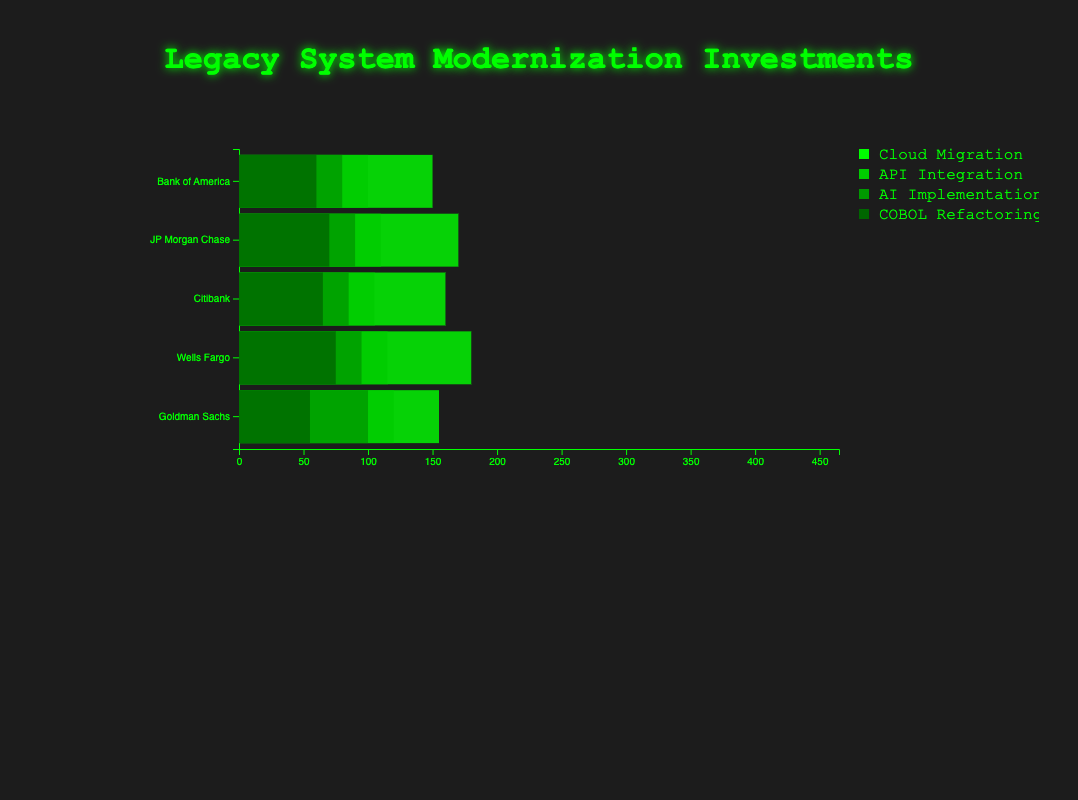What is the total allocated budget for AI implementation across all financial institutions? To find the total allocated budget for AI implementation, sum the allocated budgets from all financial institutions: (80 + 90 + 85 + 95 + 100) = 450.
Answer: 450 Which financial institution has the highest utilized budget for COBOL refactoring? Compare the utilized budgets for COBOL refactoring among all financial institutions. Bank of America utilized 60, JP Morgan Chase 68, Citibank 63, Wells Fargo 70, and Goldman Sachs 53. Wells Fargo has the highest utilized budget at 70.
Answer: Wells Fargo What is the difference between the allocated and utilized budget for cloud migration in Citibank? Subtract the utilized budget from the allocated budget for cloud migration in Citibank: 160 - 140 = 20.
Answer: 20 Which financial institution has the least total allocated budget across all modernization strategies? Sum the allocated budgets for each financial institution and compare them. Bank of America: (150 + 100 + 80 + 60) = 390, JP Morgan Chase: (170 + 110 + 90 + 70) = 440, Citibank: (160 + 105 + 85 + 65) = 415, Wells Fargo: (180 + 115 + 95 + 75) = 465, Goldman Sachs: (155 + 120 + 100 + 55) = 430. Bank of America has the least total allocated budget at 390.
Answer: Bank of America What is the average utilized budget for API integration across all financial institutions? Sum the utilized budgets for API integration from all financial institutions and divide by the number of institutions: (90 + 105 + 100 + 110 + 115) / 5 = 520 / 5 = 104.
Answer: 104 How does the allocated budget for cloud migration in JP Morgan Chase compare to that in Wells Fargo? Compare the allocated budget for cloud migration between JP Morgan Chase (170) and Wells Fargo (180). Wells Fargo has a larger allocated budget by 10 (180 - 170 = 10).
Answer: Wells Fargo allocated 10 more Which modernization strategy has the highest total utilized budget across all financial institutions? Sum the utilized budgets for each strategy across financial institutions: cloud_migration: (120 + 150 + 140 + 175 + 150) = 735, API_integration: (90 + 105 + 100 + 110 + 115) = 520, AI_implementation: (75 + 80 + 80 + 90 + 95) = 420, COBOL_refactoring: (60 + 68 + 63 + 70 + 53) = 314. Cloud migration has the highest total utilized budget at 735.
Answer: Cloud migration Which financial institution utilized more of its allocated budget for AI implementation: Bank of America or Citibank? Compare the utilized percentages of AI implementation for Bank of America (75/80 = 93.75%) and Citibank (80/85 = 94.12%). Citibank utilized a higher percentage of its allocated budget.
Answer: Citibank 